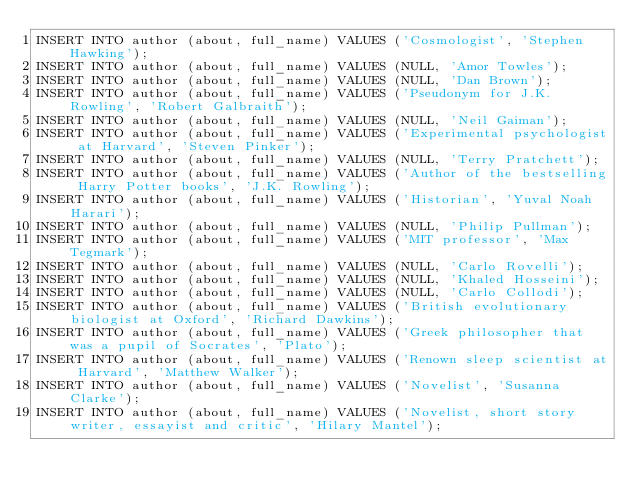<code> <loc_0><loc_0><loc_500><loc_500><_SQL_>INSERT INTO author (about, full_name) VALUES ('Cosmologist', 'Stephen Hawking');
INSERT INTO author (about, full_name) VALUES (NULL, 'Amor Towles');
INSERT INTO author (about, full_name) VALUES (NULL, 'Dan Brown');
INSERT INTO author (about, full_name) VALUES ('Pseudonym for J.K. Rowling', 'Robert Galbraith');
INSERT INTO author (about, full_name) VALUES (NULL, 'Neil Gaiman');
INSERT INTO author (about, full_name) VALUES ('Experimental psychologist at Harvard', 'Steven Pinker');
INSERT INTO author (about, full_name) VALUES (NULL, 'Terry Pratchett');
INSERT INTO author (about, full_name) VALUES ('Author of the bestselling Harry Potter books', 'J.K. Rowling');
INSERT INTO author (about, full_name) VALUES ('Historian', 'Yuval Noah Harari');
INSERT INTO author (about, full_name) VALUES (NULL, 'Philip Pullman');
INSERT INTO author (about, full_name) VALUES ('MIT professor', 'Max Tegmark');
INSERT INTO author (about, full_name) VALUES (NULL, 'Carlo Rovelli');
INSERT INTO author (about, full_name) VALUES (NULL, 'Khaled Hosseini');
INSERT INTO author (about, full_name) VALUES (NULL, 'Carlo Collodi');
INSERT INTO author (about, full_name) VALUES ('British evolutionary biologist at Oxford', 'Richard Dawkins');
INSERT INTO author (about, full_name) VALUES ('Greek philosopher that was a pupil of Socrates', 'Plato');
INSERT INTO author (about, full_name) VALUES ('Renown sleep scientist at Harvard', 'Matthew Walker');
INSERT INTO author (about, full_name) VALUES ('Novelist', 'Susanna Clarke');
INSERT INTO author (about, full_name) VALUES ('Novelist, short story writer, essayist and critic', 'Hilary Mantel');

</code> 